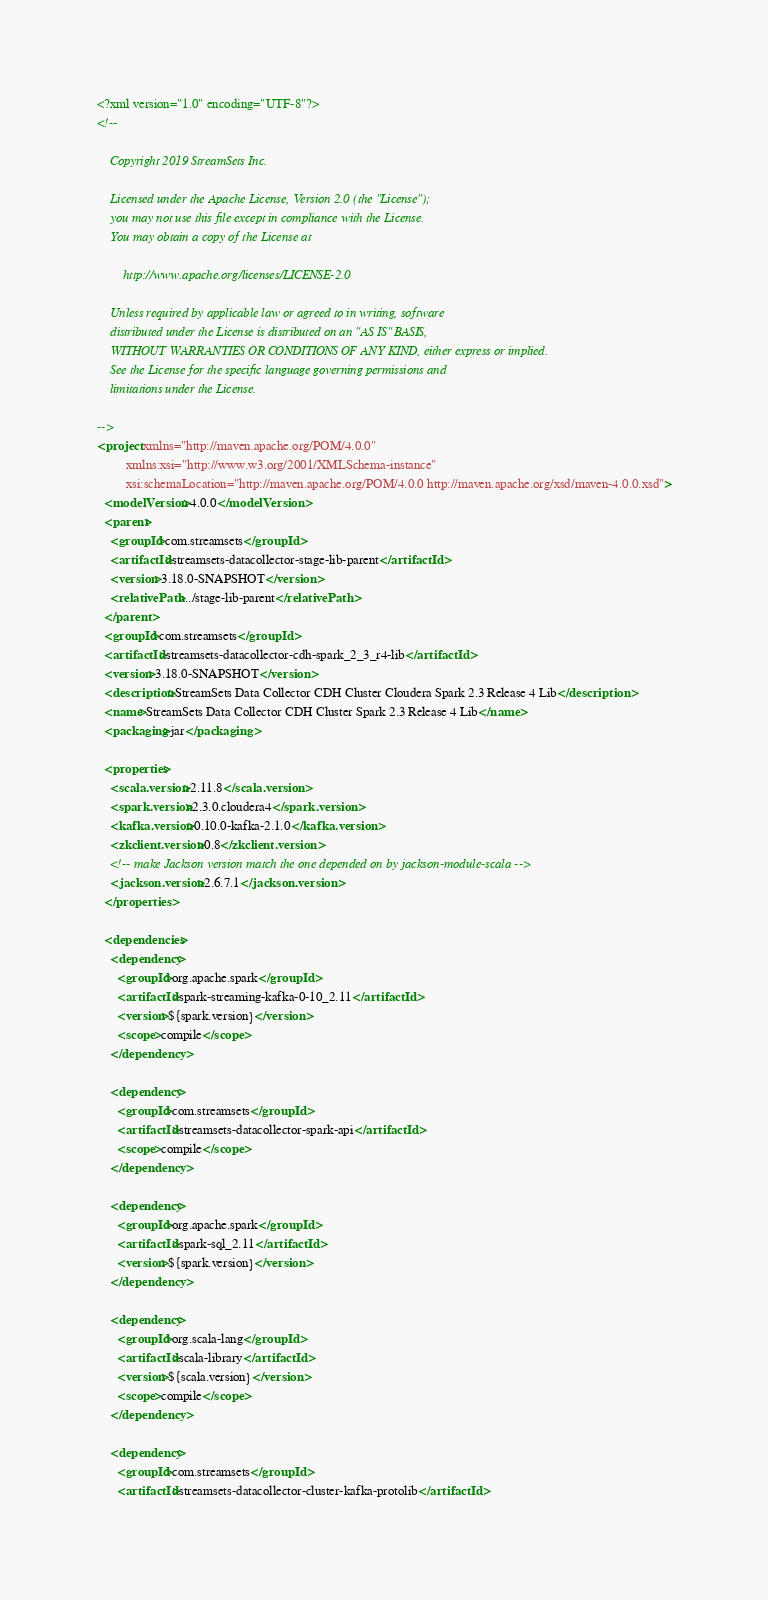Convert code to text. <code><loc_0><loc_0><loc_500><loc_500><_XML_><?xml version="1.0" encoding="UTF-8"?>
<!--

    Copyright 2019 StreamSets Inc.

    Licensed under the Apache License, Version 2.0 (the "License");
    you may not use this file except in compliance with the License.
    You may obtain a copy of the License at

        http://www.apache.org/licenses/LICENSE-2.0

    Unless required by applicable law or agreed to in writing, software
    distributed under the License is distributed on an "AS IS" BASIS,
    WITHOUT WARRANTIES OR CONDITIONS OF ANY KIND, either express or implied.
    See the License for the specific language governing permissions and
    limitations under the License.

-->
<project xmlns="http://maven.apache.org/POM/4.0.0"
         xmlns:xsi="http://www.w3.org/2001/XMLSchema-instance"
         xsi:schemaLocation="http://maven.apache.org/POM/4.0.0 http://maven.apache.org/xsd/maven-4.0.0.xsd">
  <modelVersion>4.0.0</modelVersion>
  <parent>
    <groupId>com.streamsets</groupId>
    <artifactId>streamsets-datacollector-stage-lib-parent</artifactId>
    <version>3.18.0-SNAPSHOT</version>
    <relativePath>../stage-lib-parent</relativePath>
  </parent>
  <groupId>com.streamsets</groupId>
  <artifactId>streamsets-datacollector-cdh-spark_2_3_r4-lib</artifactId>
  <version>3.18.0-SNAPSHOT</version>
  <description>StreamSets Data Collector CDH Cluster Cloudera Spark 2.3 Release 4 Lib</description>
  <name>StreamSets Data Collector CDH Cluster Spark 2.3 Release 4 Lib</name>
  <packaging>jar</packaging>

  <properties>
    <scala.version>2.11.8</scala.version>
    <spark.version>2.3.0.cloudera4</spark.version>
    <kafka.version>0.10.0-kafka-2.1.0</kafka.version>
    <zkclient.version>0.8</zkclient.version>
    <!-- make Jackson version match the one depended on by jackson-module-scala -->
    <jackson.version>2.6.7.1</jackson.version>
  </properties>

  <dependencies>
    <dependency>
      <groupId>org.apache.spark</groupId>
      <artifactId>spark-streaming-kafka-0-10_2.11</artifactId>
      <version>${spark.version}</version>
      <scope>compile</scope>
    </dependency>

    <dependency>
      <groupId>com.streamsets</groupId>
      <artifactId>streamsets-datacollector-spark-api</artifactId>
      <scope>compile</scope>
    </dependency>

    <dependency>
      <groupId>org.apache.spark</groupId>
      <artifactId>spark-sql_2.11</artifactId>
      <version>${spark.version}</version>
    </dependency>

    <dependency>
      <groupId>org.scala-lang</groupId>
      <artifactId>scala-library</artifactId>
      <version>${scala.version}</version>
      <scope>compile</scope>
    </dependency>

    <dependency>
      <groupId>com.streamsets</groupId>
      <artifactId>streamsets-datacollector-cluster-kafka-protolib</artifactId></code> 